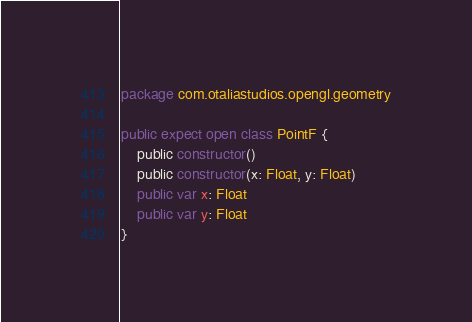Convert code to text. <code><loc_0><loc_0><loc_500><loc_500><_Kotlin_>package com.otaliastudios.opengl.geometry

public expect open class PointF {
    public constructor()
    public constructor(x: Float, y: Float)
    public var x: Float
    public var y: Float
}</code> 